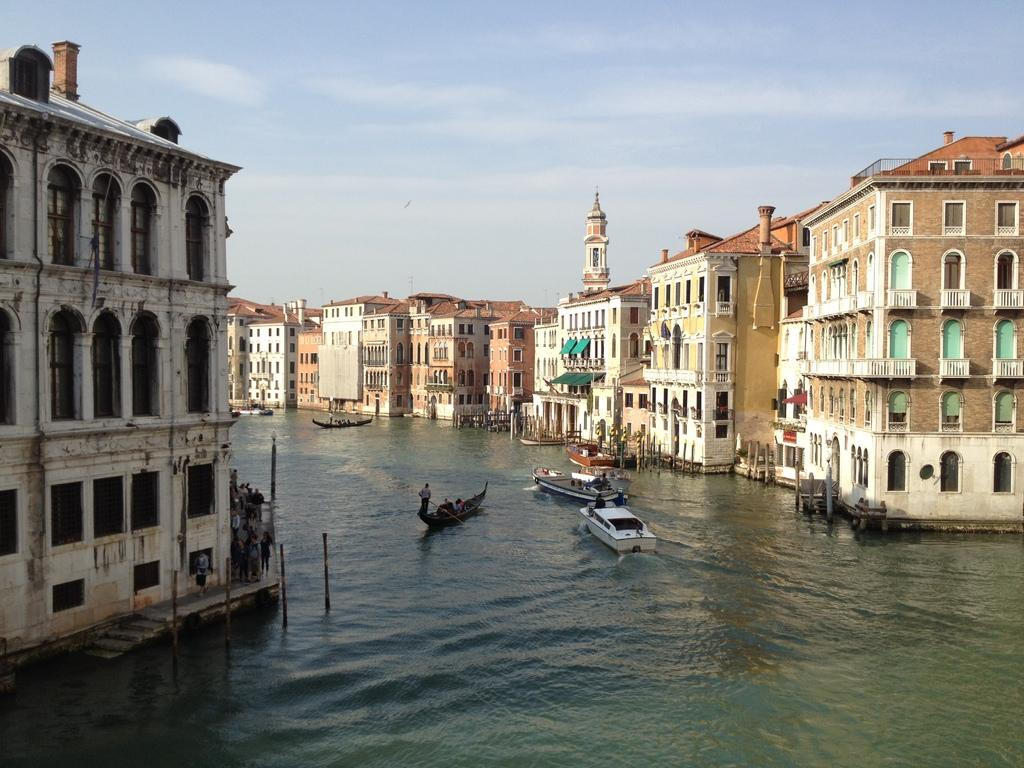What is floating on the water surface in the image? There are boats on the water surface in the image. What else can be seen in the image besides the boats? There are buildings visible in the image. What type of silver trouble is the grandfather experiencing in the image? There is no grandfather or silver trouble present in the image; it features boats on the water surface and buildings. 